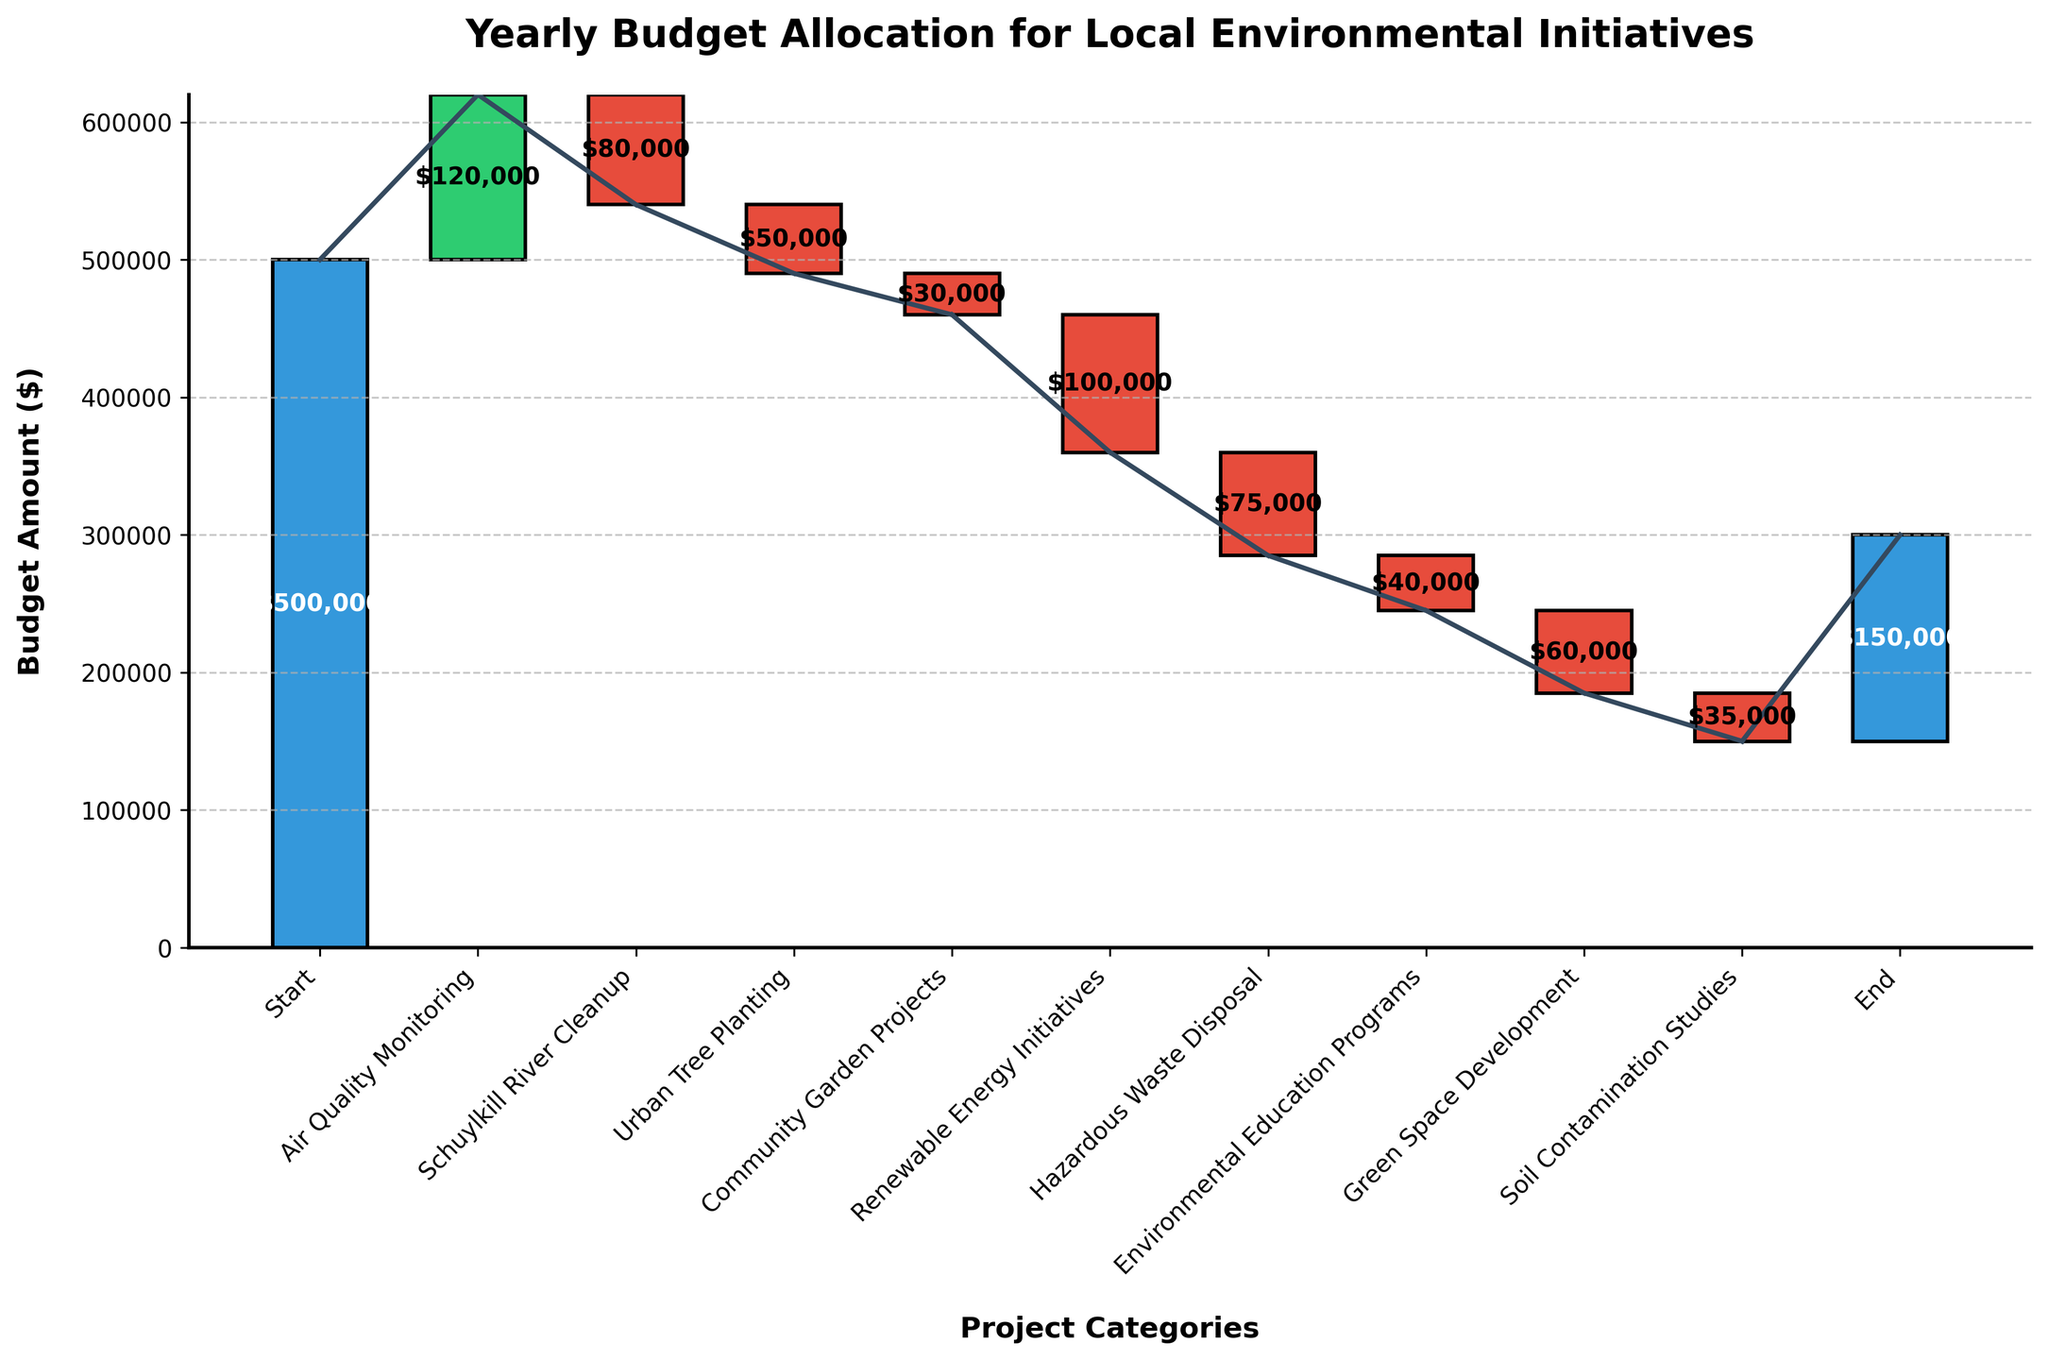What is the title of the chart? The title is displayed at the top of the chart in bold and larger font size, making it easily identifiable.
Answer: Yearly Budget Allocation for Local Environmental Initiatives What is the initial budget amount? The first bar in the chart, labeled "Start," indicates the initial budget amount at the bottom leftmost position.
Answer: $500,000 Which project category has the largest positive budget allocation? By comparing the heights of the bars with positive amounts, the "Air Quality Monitoring" bar is the tallest, indicating it has the largest positive allocation.
Answer: Air Quality Monitoring Which project category has the largest negative budget allocation? By comparing the heights of the bars with negative amounts, the "Renewable Energy Initiatives" bar is the tallest, indicating it has the largest negative allocation.
Answer: Renewable Energy Initiatives What is the cumulative budget after the "Schuylkill River Cleanup" project? To determine this, add the values of previous categories before "Schuylkill River Cleanup" and subtract its amount: $500,000 + $120,000 - $80,000.
Answer: $540,000 What is the total reduction in the budget from all project categories combined? Sum up all the negative amounts: $80,000 + $50,000 + $30,000 + $100,000 + $75,000 + $40,000 + $60,000 + $35,000.
Answer: $470,000 What is the final budget amount shown in the chart? The last bar in the chart, labeled "End," indicates the final budget amount at the bottom rightmost position.
Answer: $150,000 How does the budget allocation for "Community Garden Projects" compare to "Environmental Education Programs"? Compare the heights of the two respective bars. The "Community Garden Projects" bar is taller, implying a higher budget allocation compared to "Environmental Education Programs."
Answer: Higher What is the average positive budget allocation across all categories? Sum the positive allocations ($500,000 + $120,000) and divide by the number of positive categories (2). The calculation is (500,000 + 120,000) / 2.
Answer: $310,000 What is the cumulative budget after "Hazardous Waste Disposal"? Calculate cumulative budget by summing up previous categories and subtracting the amount for "Hazardous Waste Disposal": $500,000 + $120,000 - $80,000 - $50,000 - $30,000 - $100,000 - $75,000.
Answer: $285,000 